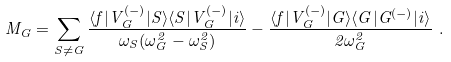Convert formula to latex. <formula><loc_0><loc_0><loc_500><loc_500>M _ { G } = \sum _ { S \ne G } \frac { \langle f | V _ { G } ^ { ( - ) } | S \rangle \langle S | V _ { G } ^ { ( - ) } | i \rangle } { \omega _ { S } ( \omega _ { G } ^ { 2 } - \omega _ { S } ^ { 2 } ) } - \frac { \langle f | V _ { G } ^ { ( - ) } | G \rangle \langle G | G ^ { ( - ) } | i \rangle } { 2 \omega _ { G } ^ { 2 } } \ .</formula> 